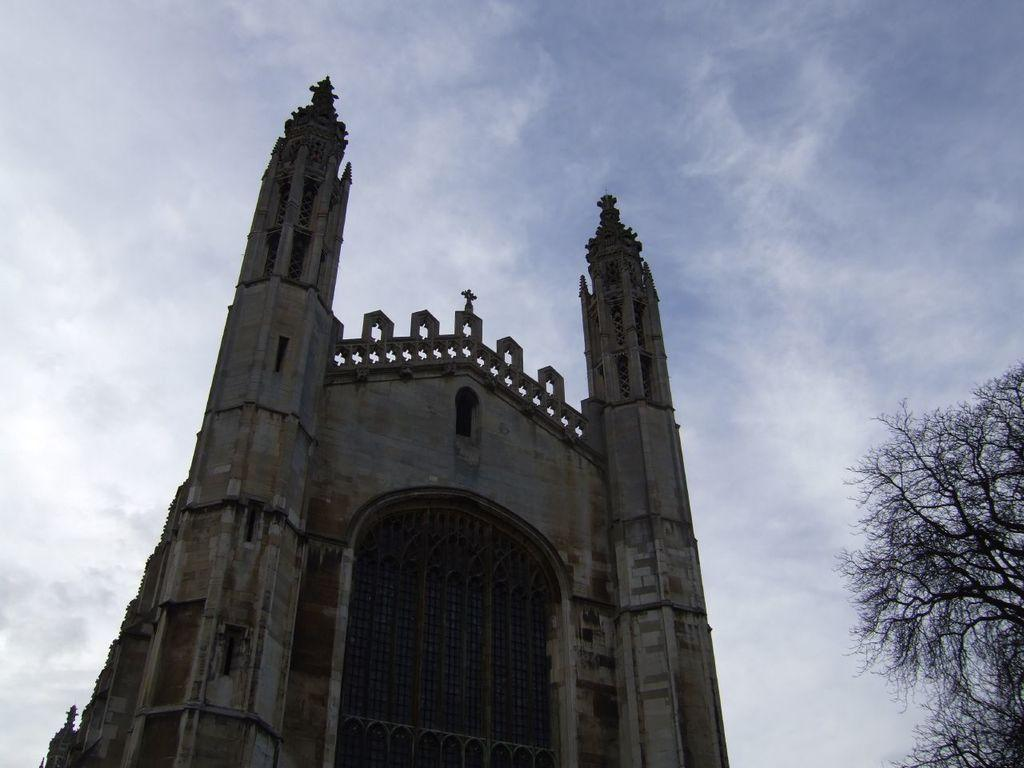What is the main structure in the middle of the image? There is a church in the middle of the image. What type of vegetation is on the right side of the image? There are trees on the right side of the image. What is visible at the top of the image? The sky is visible at the top of the image. What type of flesh can be seen hanging from the trees in the image? There is no flesh present in the image; it features a church and trees. What list is visible on the church in the image? There is no list present on the church in the image. 